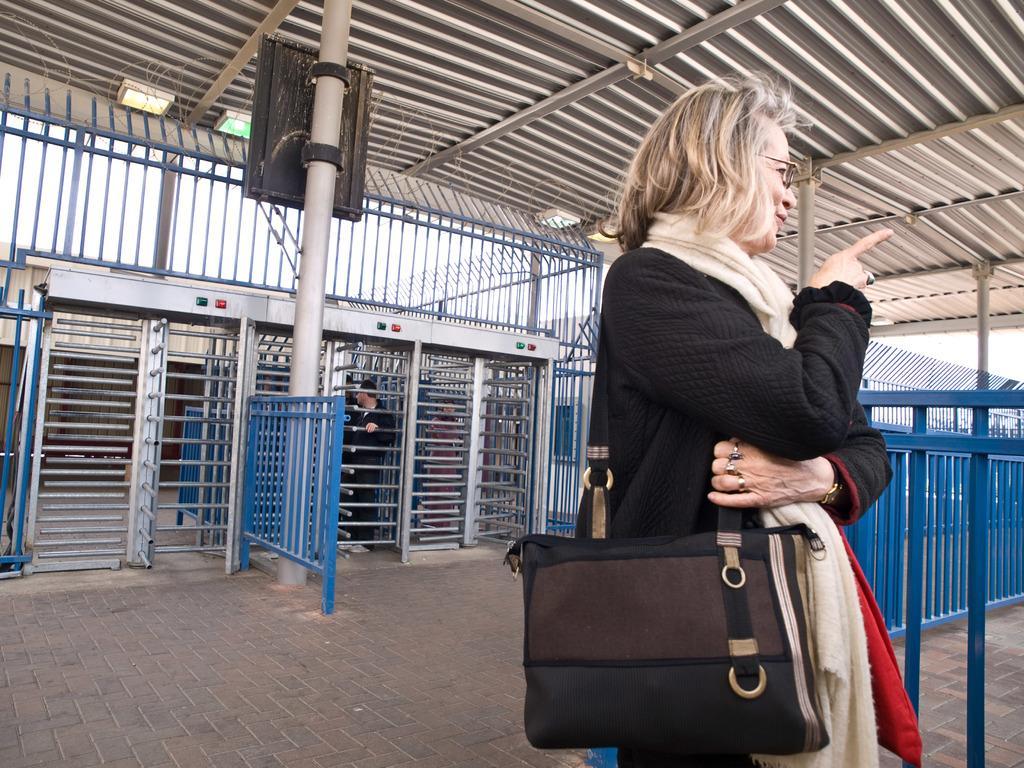In one or two sentences, can you explain what this image depicts? In this image we can see women wearing a bag. At the background we can see a iron gate. 